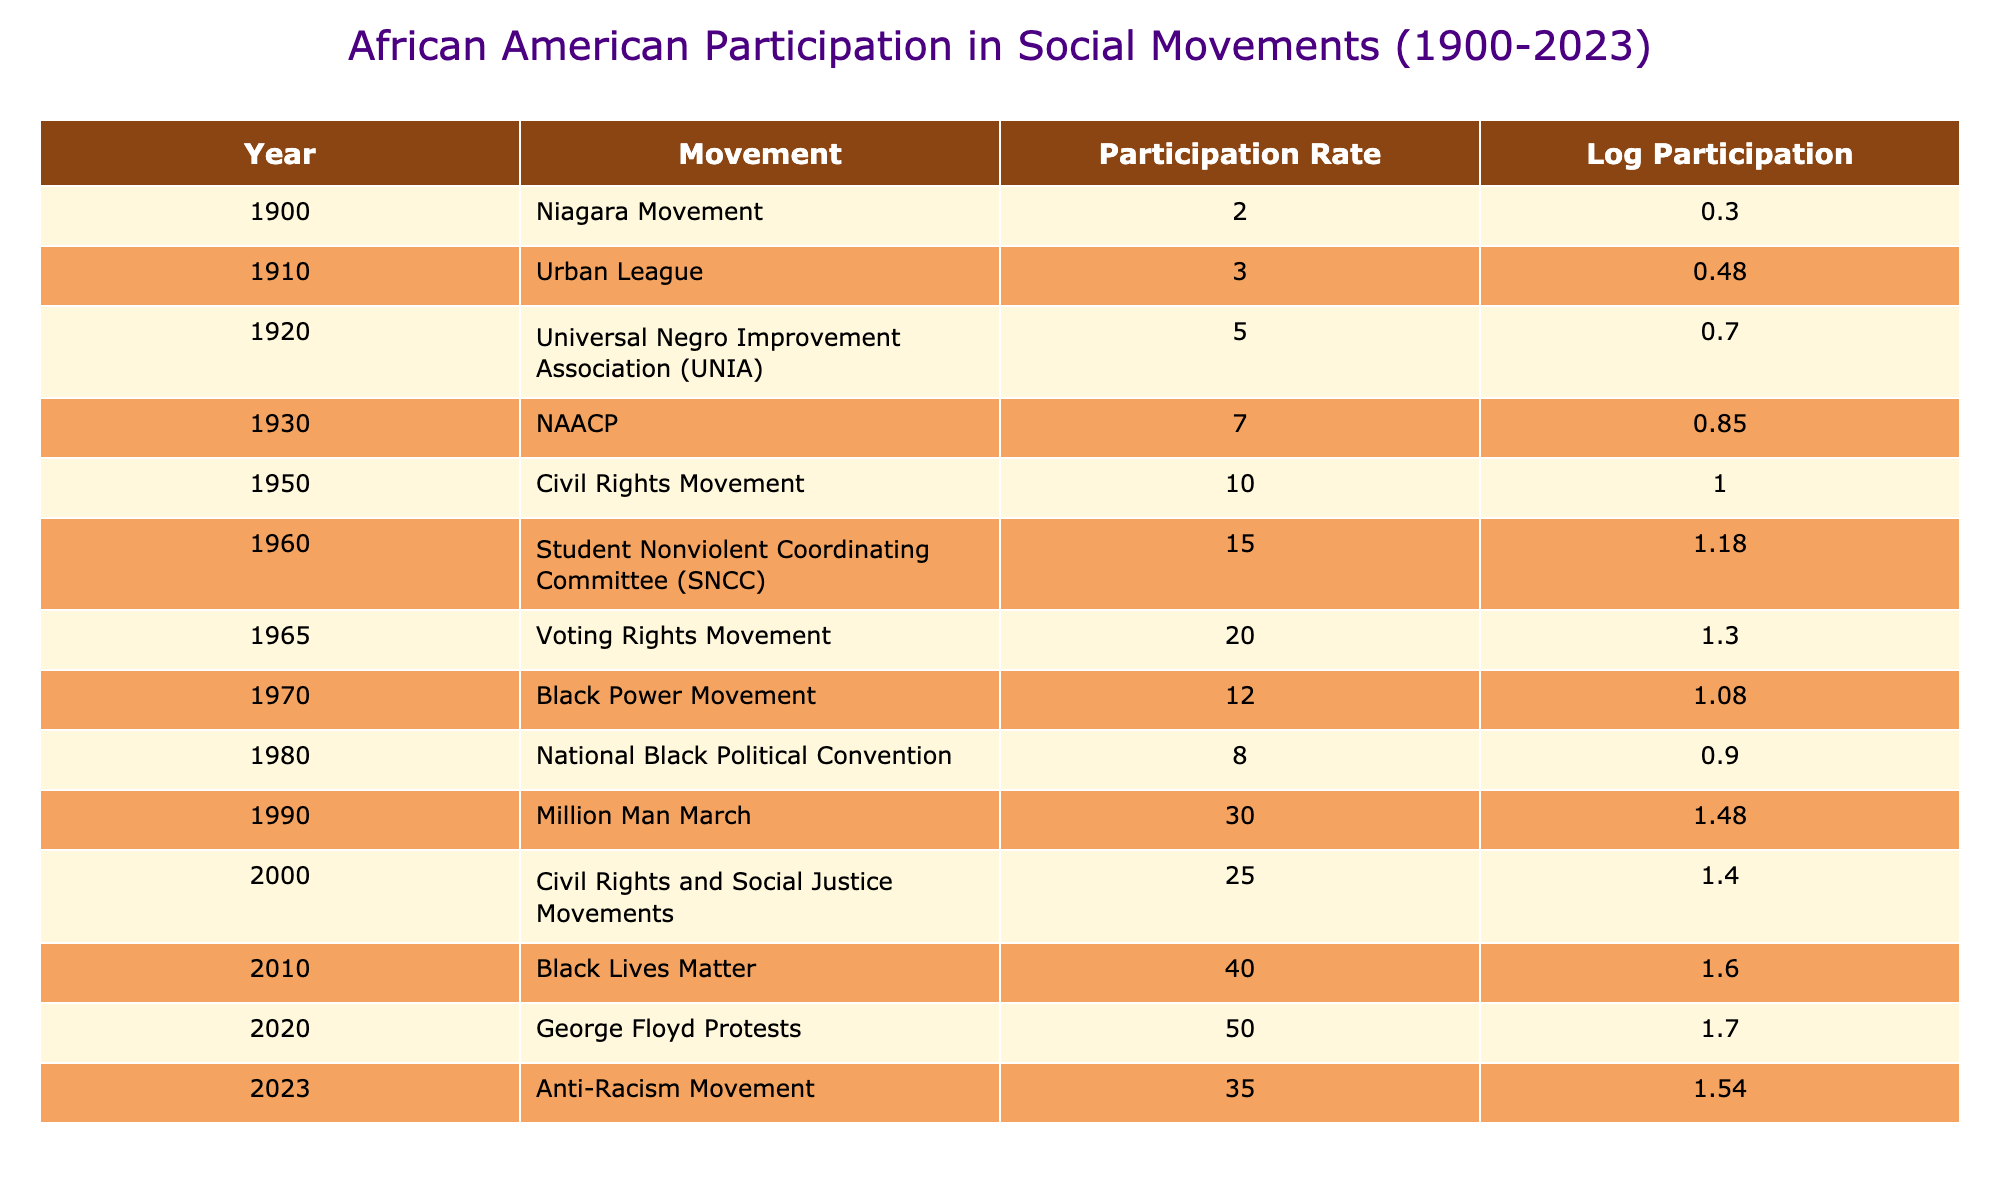What was the participation rate in the Civil Rights Movement? The table shows that the participation rate for the Civil Rights Movement in 1950 was 10.0.
Answer: 10.0 What is the log participation rate for the Black Lives Matter movement? The log of the participation rate for the Black Lives Matter movement in 2010, which is 40.0, is calculated as log10(40.0) = 1.60 when rounded to two decimal places.
Answer: 1.60 Which social movement had the highest participation rate? The highest participation rate in the table is 50.0 for the George Floyd Protests in 2020.
Answer: 50.0 Calculate the average participation rate for the movements from 2000 to 2023. The participation rates from 2000 to 2023 are 25.0, 40.0, 50.0, and 35.0. Summing these gives 25 + 40 + 50 + 35 = 150, and there are 4 movements, so the average participation rate is 150 / 4 = 37.5.
Answer: 37.5 Did the participation rate in the Voting Rights Movement exceed that of the Black Power Movement? The participation rate for the Voting Rights Movement in 1965 is 20.0, while for the Black Power Movement in 1970, it is 12.0. Since 20.0 is greater than 12.0, the statement is true.
Answer: Yes In which decade did the Niagara Movement have the lowest recorded participation? The Niagara Movement had the lowest recorded participation of 2.0 in 1900, which is in the early 20th century or specifically in the 1900s decade.
Answer: 1900s How do the participation rates from 1990 to 2010 compare? The participation rates from 1990 to 2010 are 30.0 and 40.0 respectively, indicating an increase of 10.0 in participation rates over this period.
Answer: Increased by 10.0 What was the change in participation rate from the Million Man March to the Civil Rights and Social Justice Movements? The participation rate for the Million Man March in 1990 is 30.0, and for the Civil Rights and Social Justice Movements in 2000, it is 25.0. The change is a decrease of 30.0 - 25.0 = 5.0.
Answer: Decreased by 5.0 Which movement had a log participation rate of approximately 1.91? The log participation rate around 1.91 corresponds to approximately 78.0, but since it's not listed in the table, we can refer to the highest is 50.0 for the George Floyd Protests. The closest in the table is likely the 2010 Black Lives Matter with a log of 1.60, as no data point exactly matches 1.91.
Answer: None 